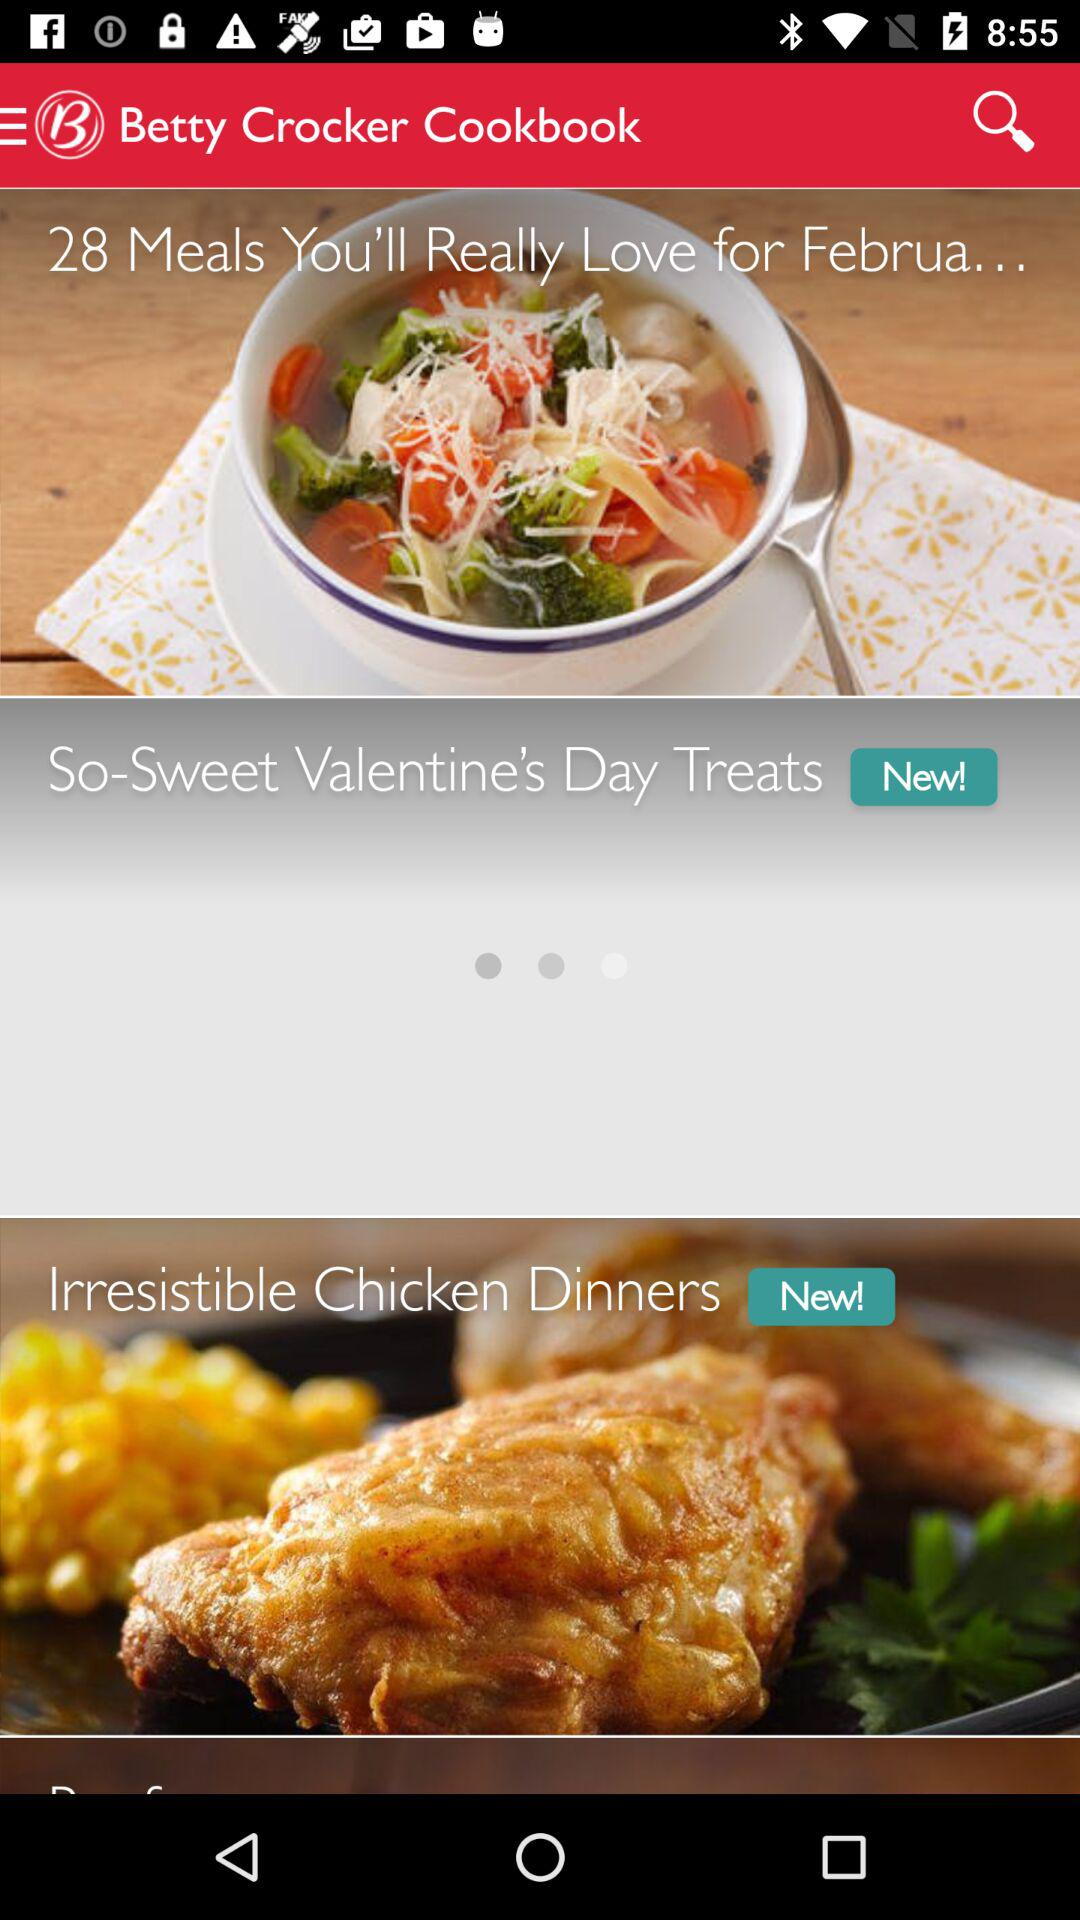What is the application name? The application name is "Betty Crocker Cookbook". 